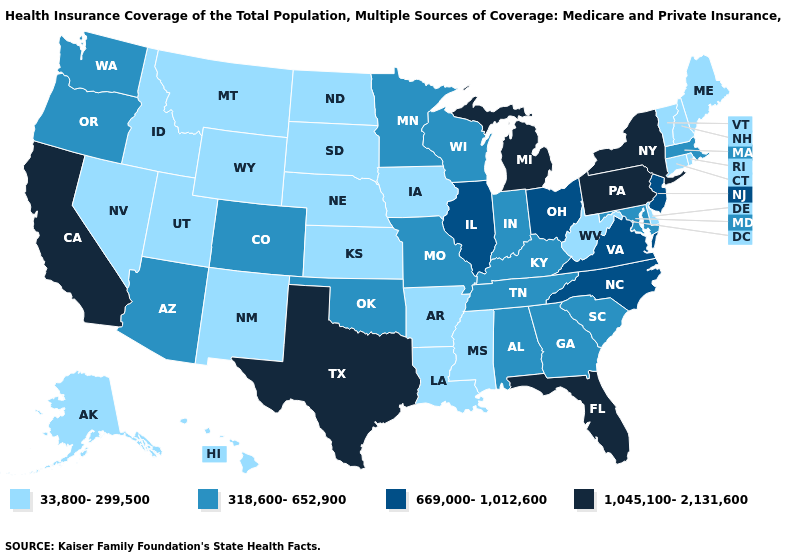Does the first symbol in the legend represent the smallest category?
Be succinct. Yes. Does Vermont have the lowest value in the Northeast?
Give a very brief answer. Yes. Name the states that have a value in the range 669,000-1,012,600?
Give a very brief answer. Illinois, New Jersey, North Carolina, Ohio, Virginia. What is the value of Virginia?
Short answer required. 669,000-1,012,600. Name the states that have a value in the range 1,045,100-2,131,600?
Write a very short answer. California, Florida, Michigan, New York, Pennsylvania, Texas. Name the states that have a value in the range 1,045,100-2,131,600?
Write a very short answer. California, Florida, Michigan, New York, Pennsylvania, Texas. Name the states that have a value in the range 33,800-299,500?
Keep it brief. Alaska, Arkansas, Connecticut, Delaware, Hawaii, Idaho, Iowa, Kansas, Louisiana, Maine, Mississippi, Montana, Nebraska, Nevada, New Hampshire, New Mexico, North Dakota, Rhode Island, South Dakota, Utah, Vermont, West Virginia, Wyoming. Among the states that border North Dakota , which have the highest value?
Write a very short answer. Minnesota. Does Missouri have a lower value than Ohio?
Answer briefly. Yes. What is the lowest value in the USA?
Give a very brief answer. 33,800-299,500. How many symbols are there in the legend?
Give a very brief answer. 4. Name the states that have a value in the range 669,000-1,012,600?
Give a very brief answer. Illinois, New Jersey, North Carolina, Ohio, Virginia. Name the states that have a value in the range 669,000-1,012,600?
Concise answer only. Illinois, New Jersey, North Carolina, Ohio, Virginia. Does Alabama have a lower value than Arizona?
Quick response, please. No. Among the states that border Tennessee , which have the highest value?
Be succinct. North Carolina, Virginia. 